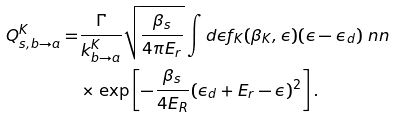<formula> <loc_0><loc_0><loc_500><loc_500>Q _ { s , b \to a } ^ { K } = & \frac { \Gamma } { k _ { b \to a } ^ { K } } \sqrt { \frac { \beta _ { s } } { 4 \pi E _ { r } } } \int d \epsilon f _ { K } ( \beta _ { K } , \epsilon ) ( \epsilon - \epsilon _ { d } ) \ n n \\ & \times \exp \left [ - \frac { \beta _ { s } } { 4 E _ { R } } ( \epsilon _ { d } + E _ { r } - \epsilon ) ^ { 2 } \right ] .</formula> 